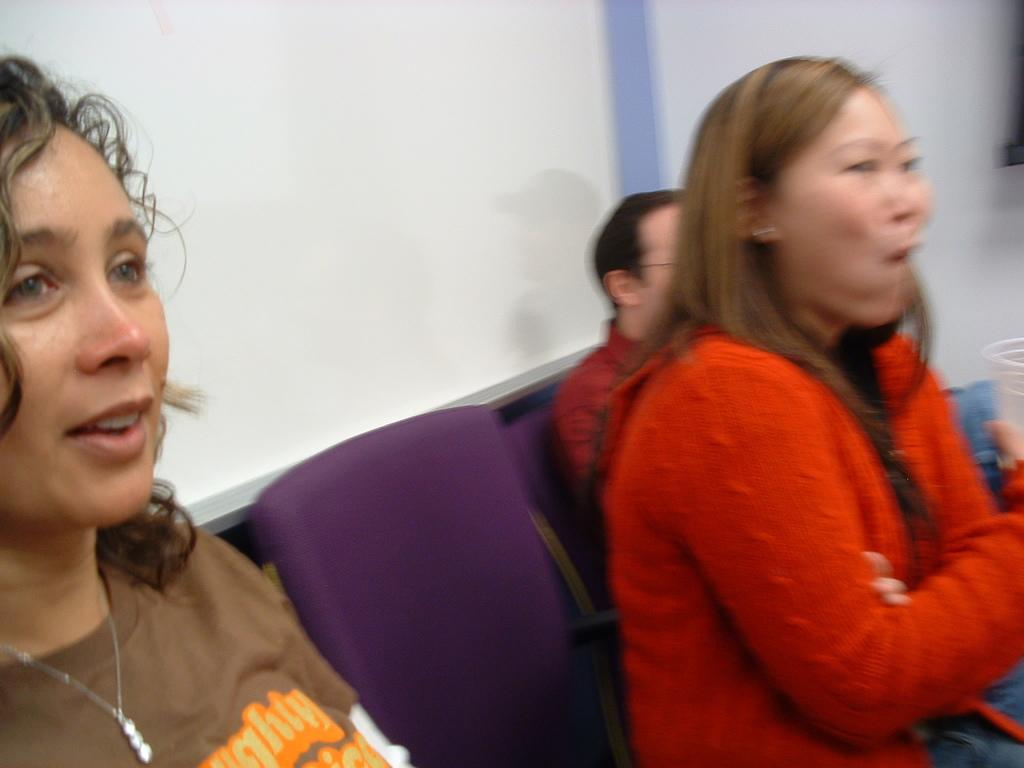Who or what is present in the image? There are people in the image. What objects are visible in the image that the people might use? There are chairs in the image that the people might use. What type of background can be seen in the image? There is a wall in the image. What type of doll is sitting on the wall in the image? There is no doll present in the image; only people, chairs, and a wall are visible. 